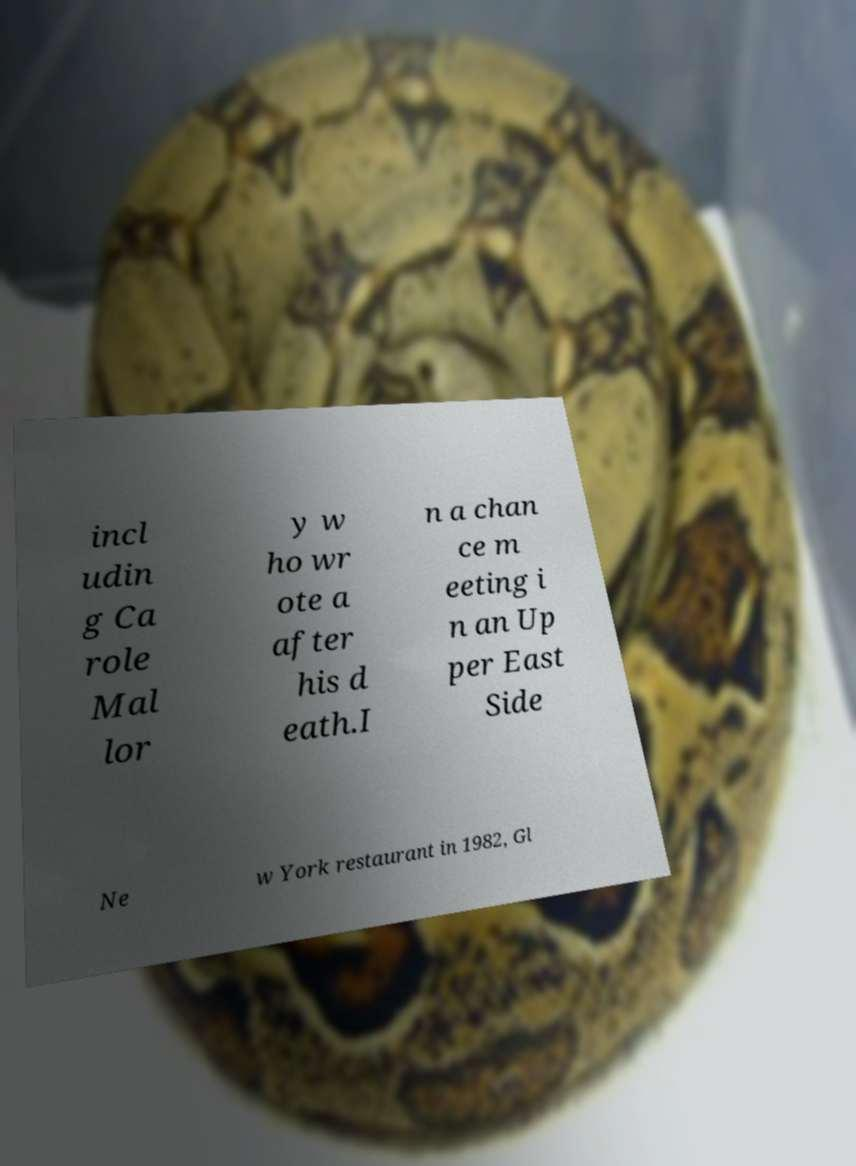There's text embedded in this image that I need extracted. Can you transcribe it verbatim? incl udin g Ca role Mal lor y w ho wr ote a after his d eath.I n a chan ce m eeting i n an Up per East Side Ne w York restaurant in 1982, Gl 